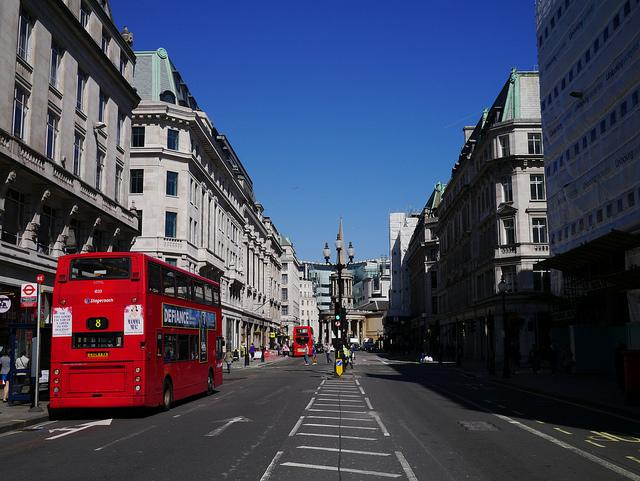How many double-decker buses are loading on the left side of the street?

Choices:
A) one
B) four
C) two
D) six two 